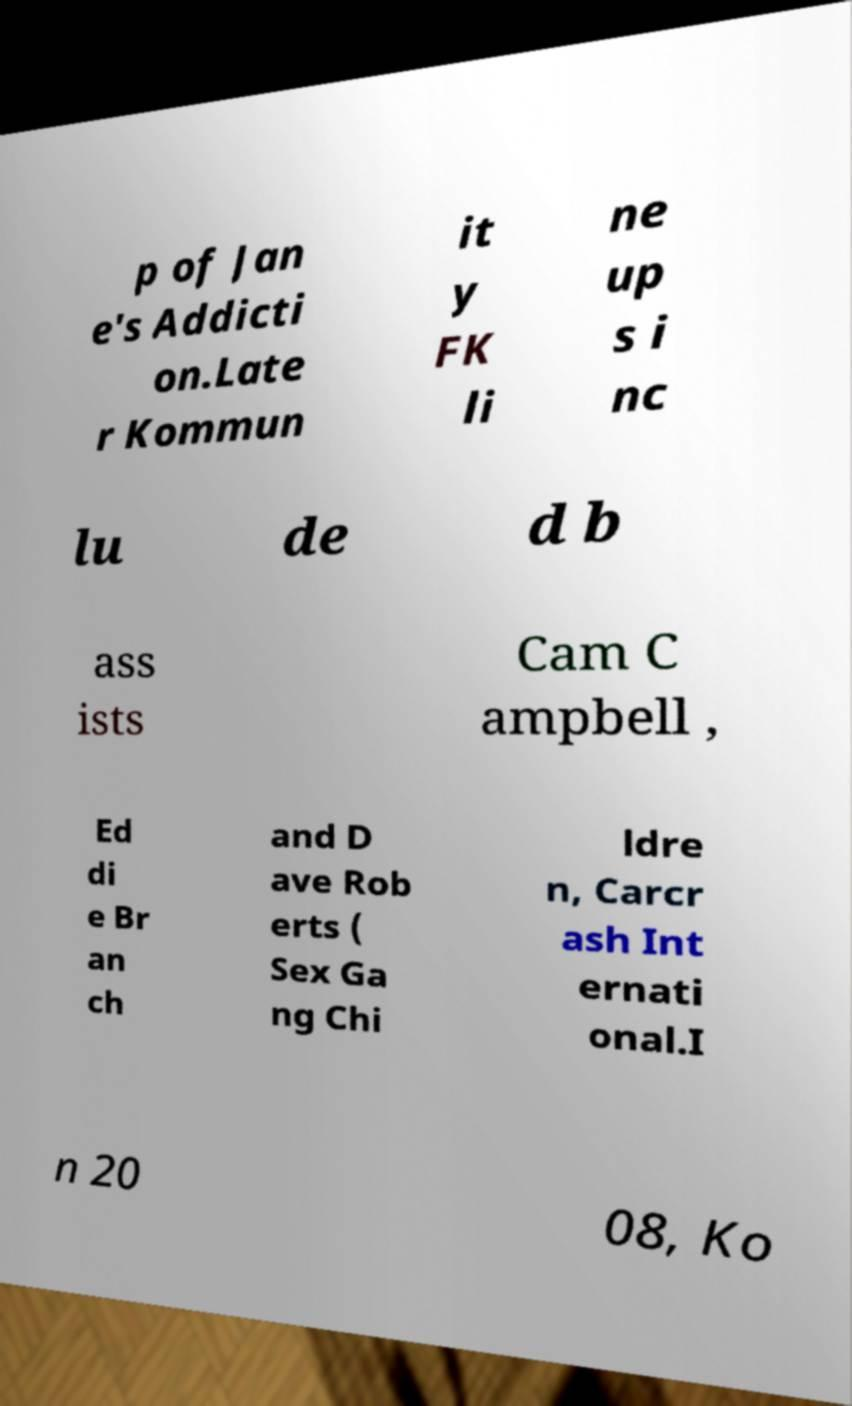Can you read and provide the text displayed in the image?This photo seems to have some interesting text. Can you extract and type it out for me? p of Jan e's Addicti on.Late r Kommun it y FK li ne up s i nc lu de d b ass ists Cam C ampbell , Ed di e Br an ch and D ave Rob erts ( Sex Ga ng Chi ldre n, Carcr ash Int ernati onal.I n 20 08, Ko 